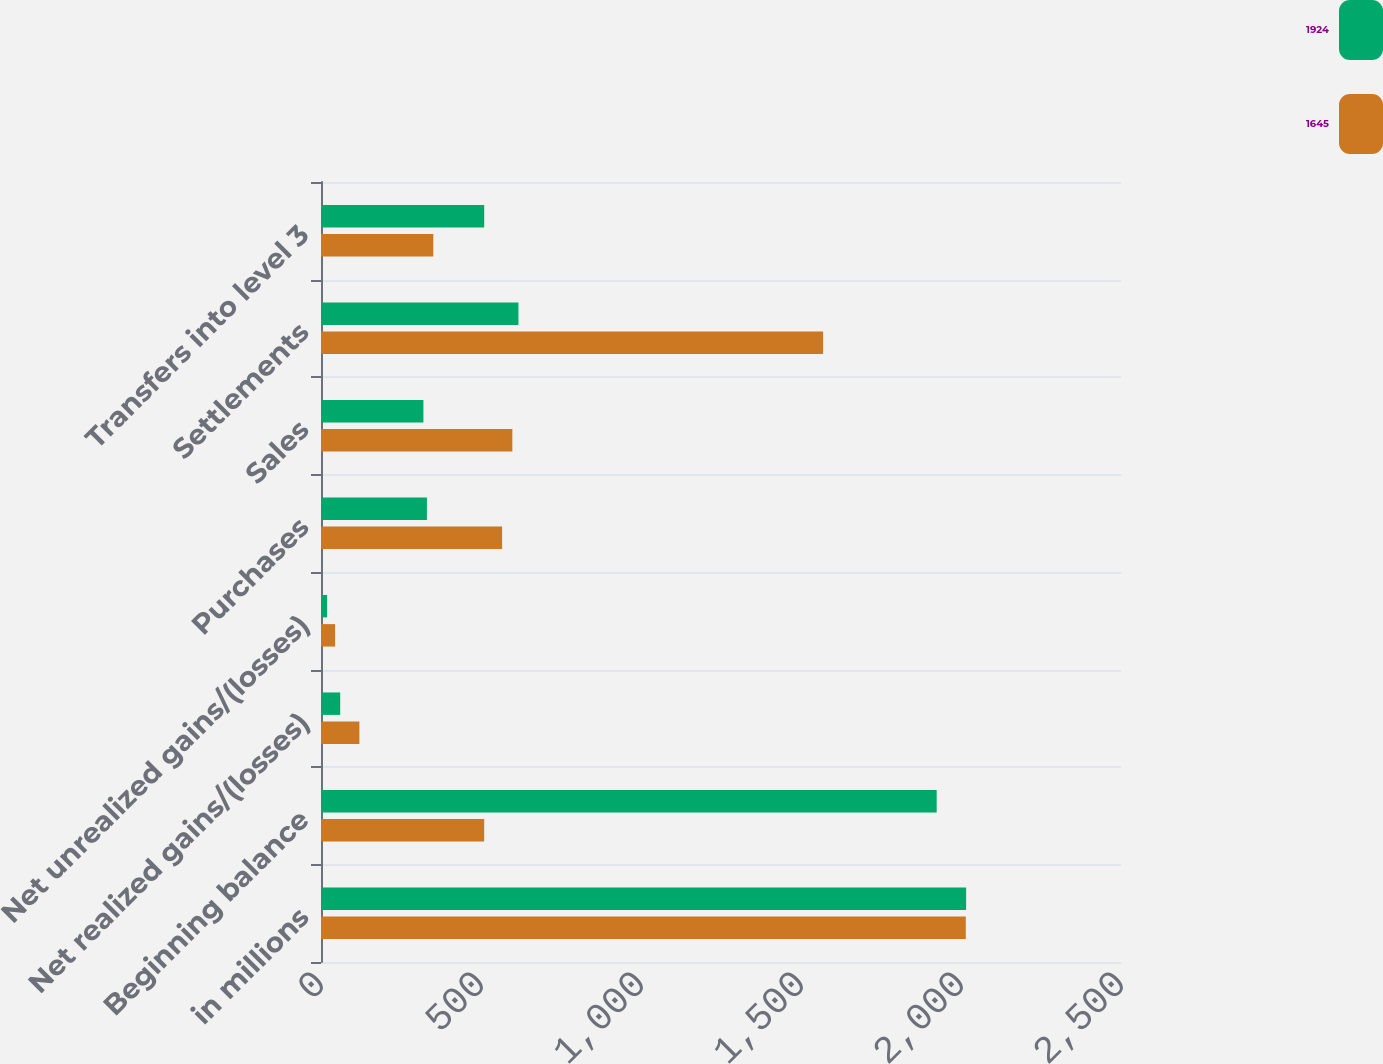Convert chart to OTSL. <chart><loc_0><loc_0><loc_500><loc_500><stacked_bar_chart><ecel><fcel>in millions<fcel>Beginning balance<fcel>Net realized gains/(losses)<fcel>Net unrealized gains/(losses)<fcel>Purchases<fcel>Sales<fcel>Settlements<fcel>Transfers into level 3<nl><fcel>1924<fcel>2016<fcel>1924<fcel>60<fcel>19<fcel>331<fcel>320<fcel>617<fcel>510<nl><fcel>1645<fcel>2015<fcel>510<fcel>120<fcel>44<fcel>566<fcel>598<fcel>1569<fcel>351<nl></chart> 